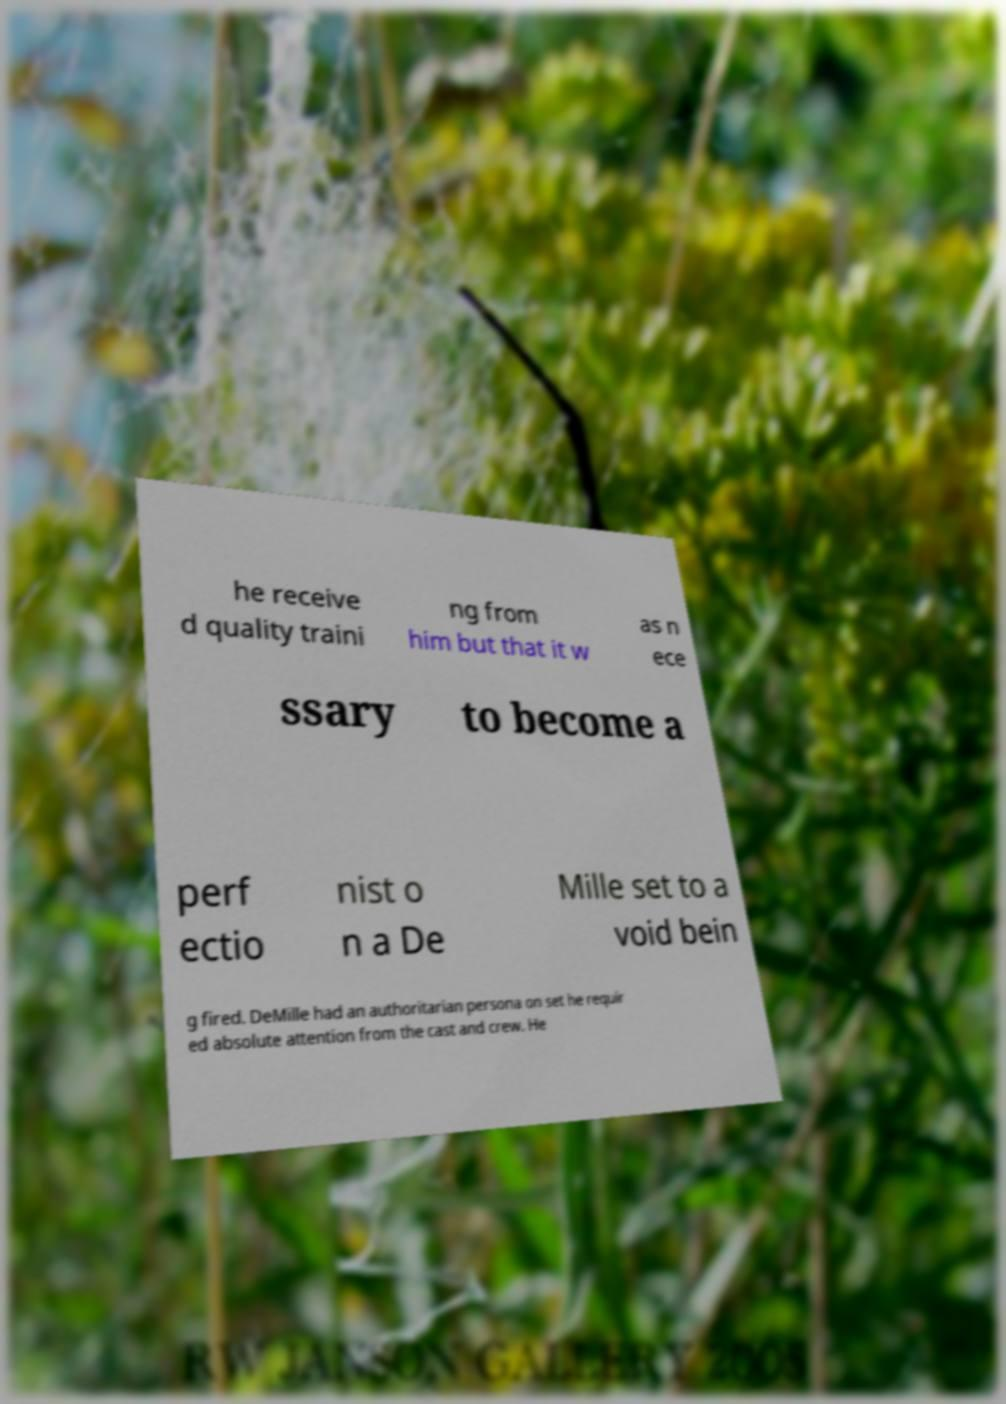Can you read and provide the text displayed in the image?This photo seems to have some interesting text. Can you extract and type it out for me? he receive d quality traini ng from him but that it w as n ece ssary to become a perf ectio nist o n a De Mille set to a void bein g fired. DeMille had an authoritarian persona on set he requir ed absolute attention from the cast and crew. He 